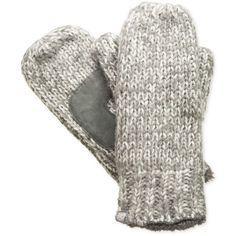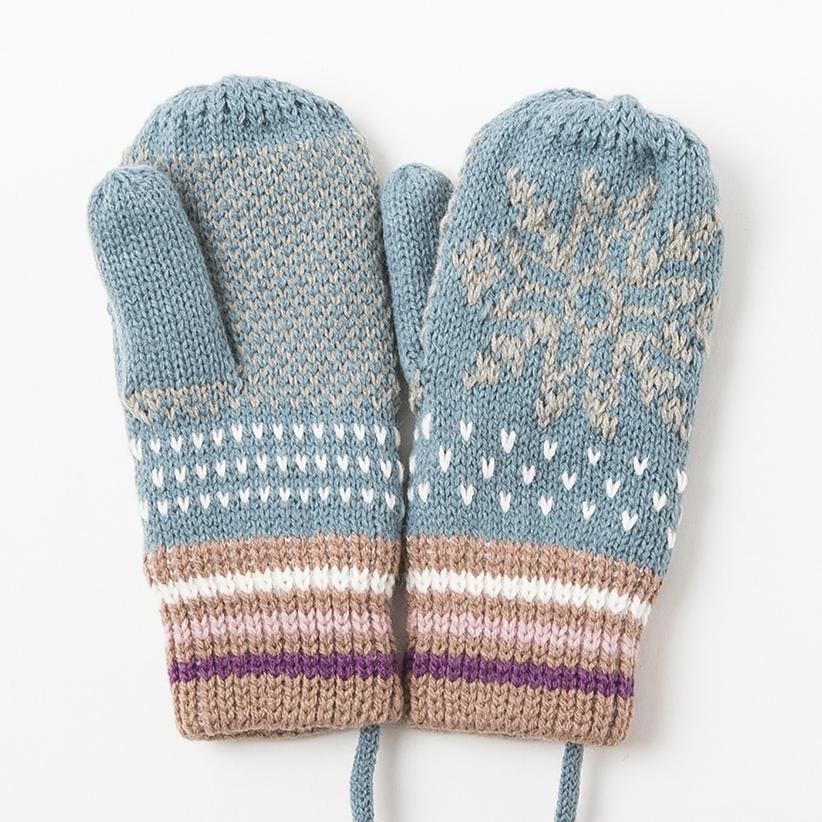The first image is the image on the left, the second image is the image on the right. Assess this claim about the two images: "The image contains fingerless mittens/gloves.". Correct or not? Answer yes or no. No. The first image is the image on the left, the second image is the image on the right. For the images shown, is this caption "There is at least one pair of convertible fingerless gloves." true? Answer yes or no. No. 